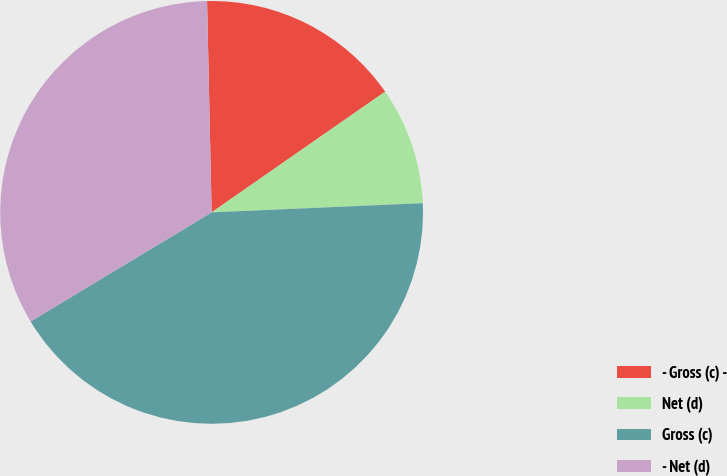Convert chart to OTSL. <chart><loc_0><loc_0><loc_500><loc_500><pie_chart><fcel>- Gross (c) -<fcel>Net (d)<fcel>Gross (c)<fcel>- Net (d)<nl><fcel>15.67%<fcel>8.98%<fcel>42.06%<fcel>33.29%<nl></chart> 